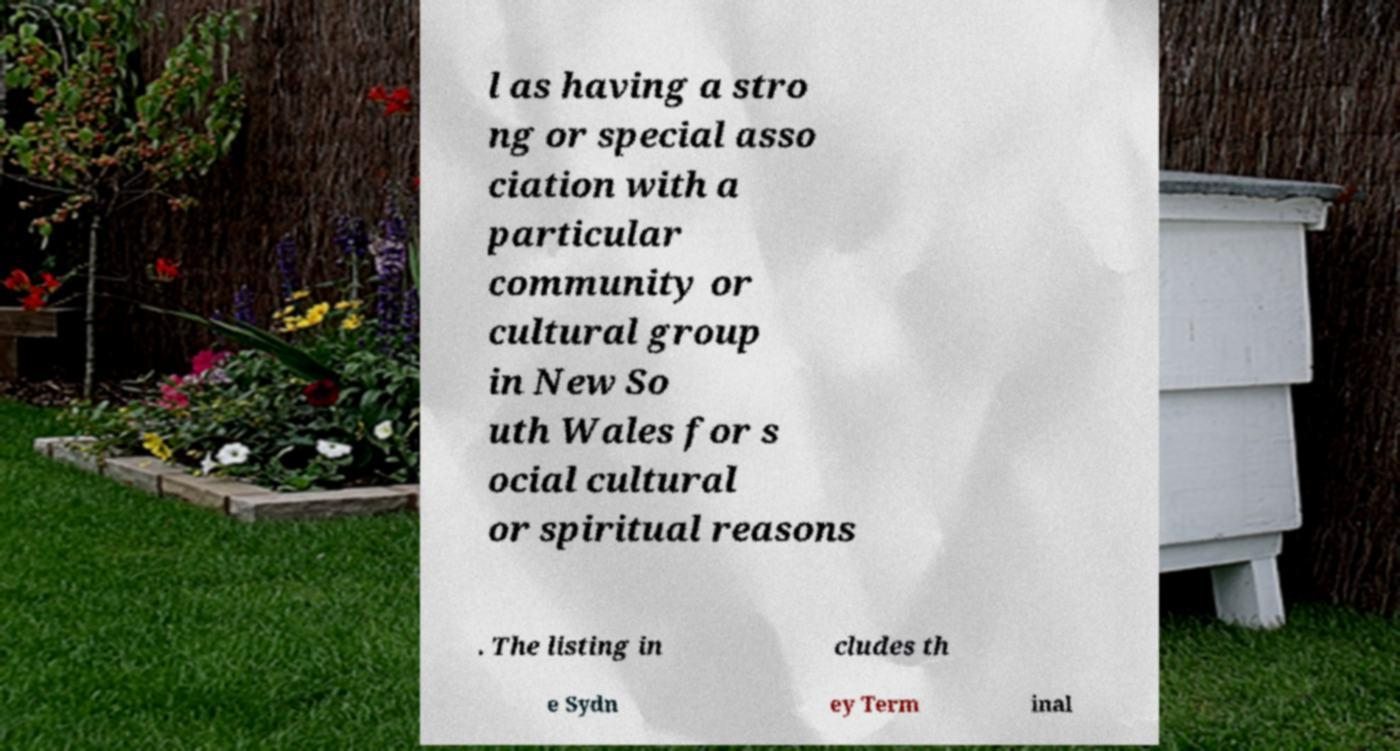For documentation purposes, I need the text within this image transcribed. Could you provide that? l as having a stro ng or special asso ciation with a particular community or cultural group in New So uth Wales for s ocial cultural or spiritual reasons . The listing in cludes th e Sydn ey Term inal 